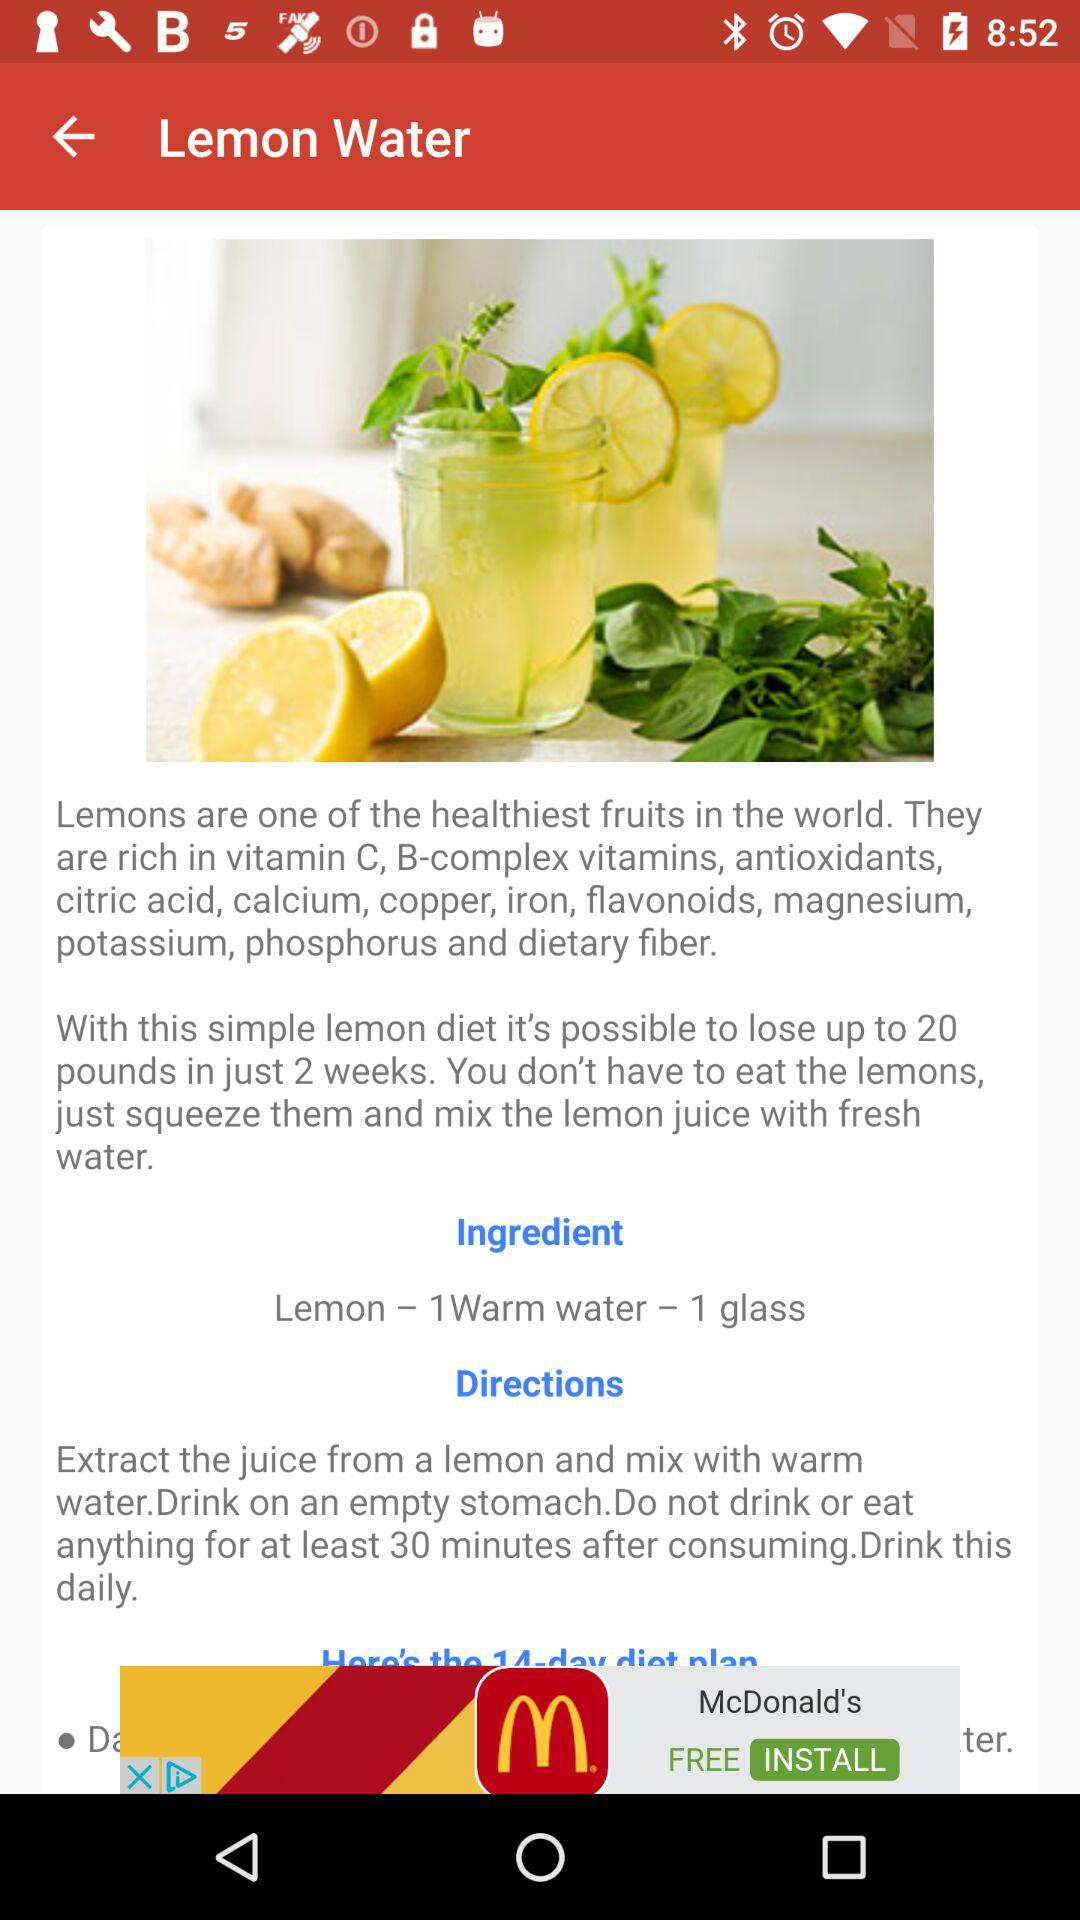How many days does the lemon diet plan last?
Answer the question using a single word or phrase. 14 days 